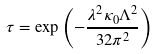<formula> <loc_0><loc_0><loc_500><loc_500>\tau = \exp { \left ( - \frac { \lambda ^ { 2 } \kappa _ { 0 } \Lambda ^ { 2 } } { 3 2 \pi ^ { 2 } } \right ) }</formula> 